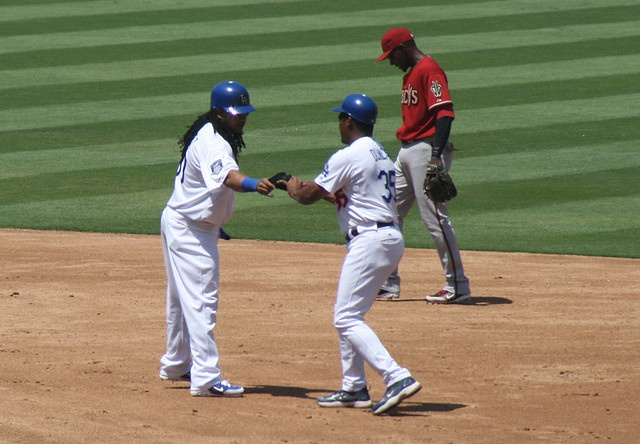Describe the objects in this image and their specific colors. I can see people in darkgreen, lavender, gray, darkgray, and black tones, people in darkgreen, lavender, gray, and darkgray tones, people in darkgreen, black, gray, maroon, and brown tones, baseball glove in darkgreen, black, and gray tones, and baseball glove in darkgreen and black tones in this image. 